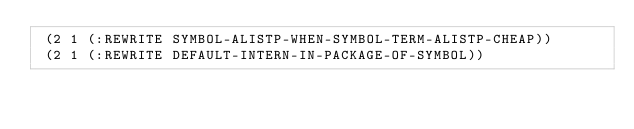<code> <loc_0><loc_0><loc_500><loc_500><_Lisp_> (2 1 (:REWRITE SYMBOL-ALISTP-WHEN-SYMBOL-TERM-ALISTP-CHEAP))
 (2 1 (:REWRITE DEFAULT-INTERN-IN-PACKAGE-OF-SYMBOL))</code> 